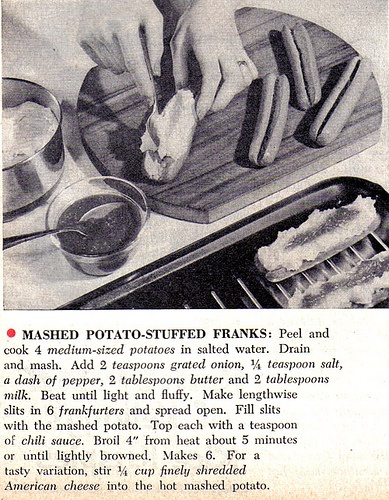Describe the objects in this image and their specific colors. I can see bowl in lightyellow, gray, darkgray, black, and lightgray tones, people in lightyellow, darkgray, and lightgray tones, people in lightyellow, darkgray, and lightgray tones, hot dog in lightyellow, darkgray, lightgray, and gray tones, and bowl in lightyellow, gray, darkgray, black, and lightgray tones in this image. 